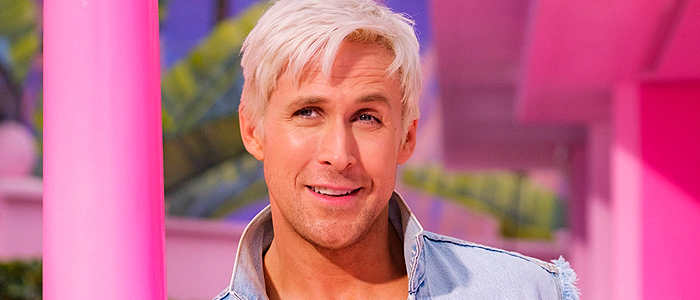Can you describe the possible setting or event where this photo might have been taken? The vibrant pink and yellow backdrop suggests a lively and possibly casual event setting, like a modern art exhibition or a creative media event. The informal yet trendy attire of the man supports the idea of an artistic or cultural gathering. 